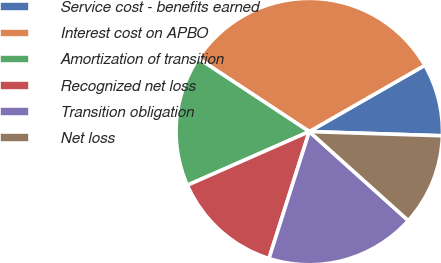Convert chart. <chart><loc_0><loc_0><loc_500><loc_500><pie_chart><fcel>Service cost - benefits earned<fcel>Interest cost on APBO<fcel>Amortization of transition<fcel>Recognized net loss<fcel>Transition obligation<fcel>Net loss<nl><fcel>8.79%<fcel>32.43%<fcel>15.88%<fcel>13.51%<fcel>18.24%<fcel>11.15%<nl></chart> 